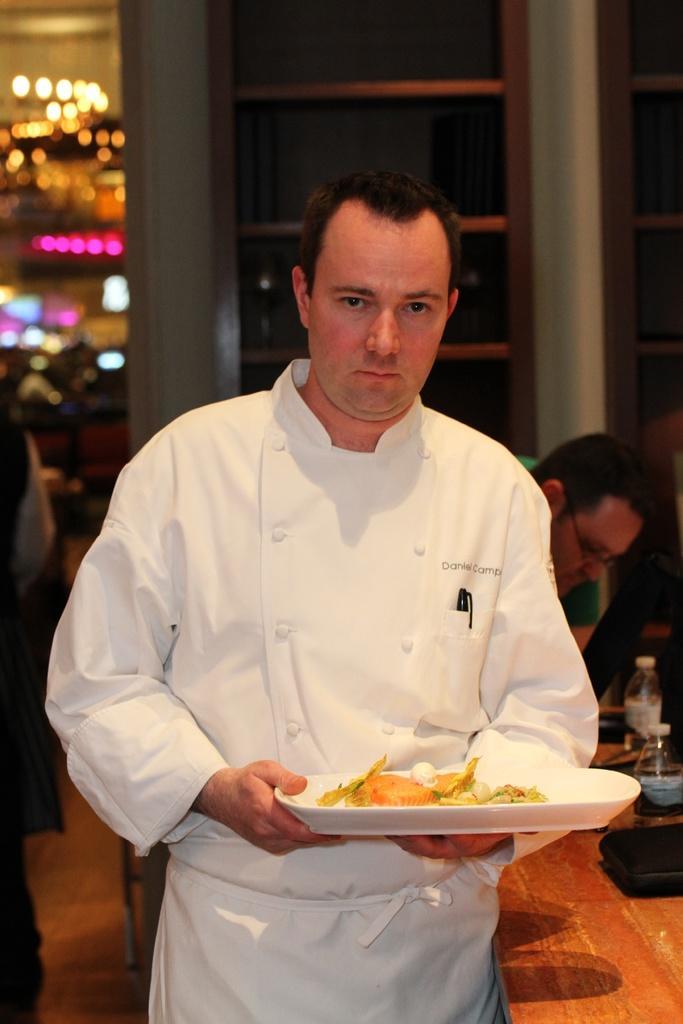Please provide a concise description of this image. In this image we can see two persons. One person wearing white dress is holding a plate containing food in it. To the right side, we can see two bottles and a tray has placed a table. In the background we can see some lights. 